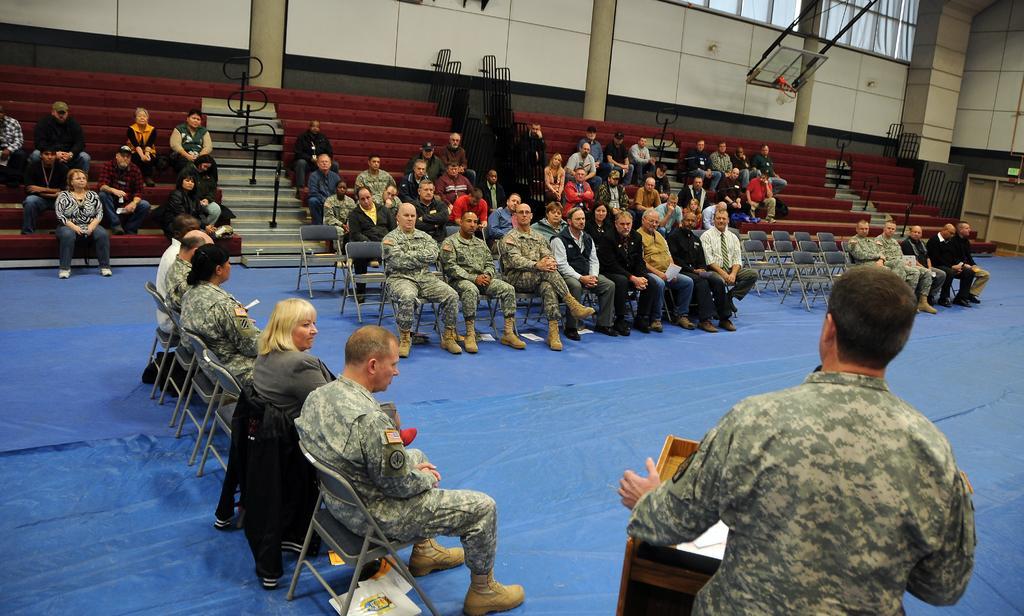In one or two sentences, can you explain what this image depicts? In this picture , at the bottom right hand corner and on the left there people who are sitting. 